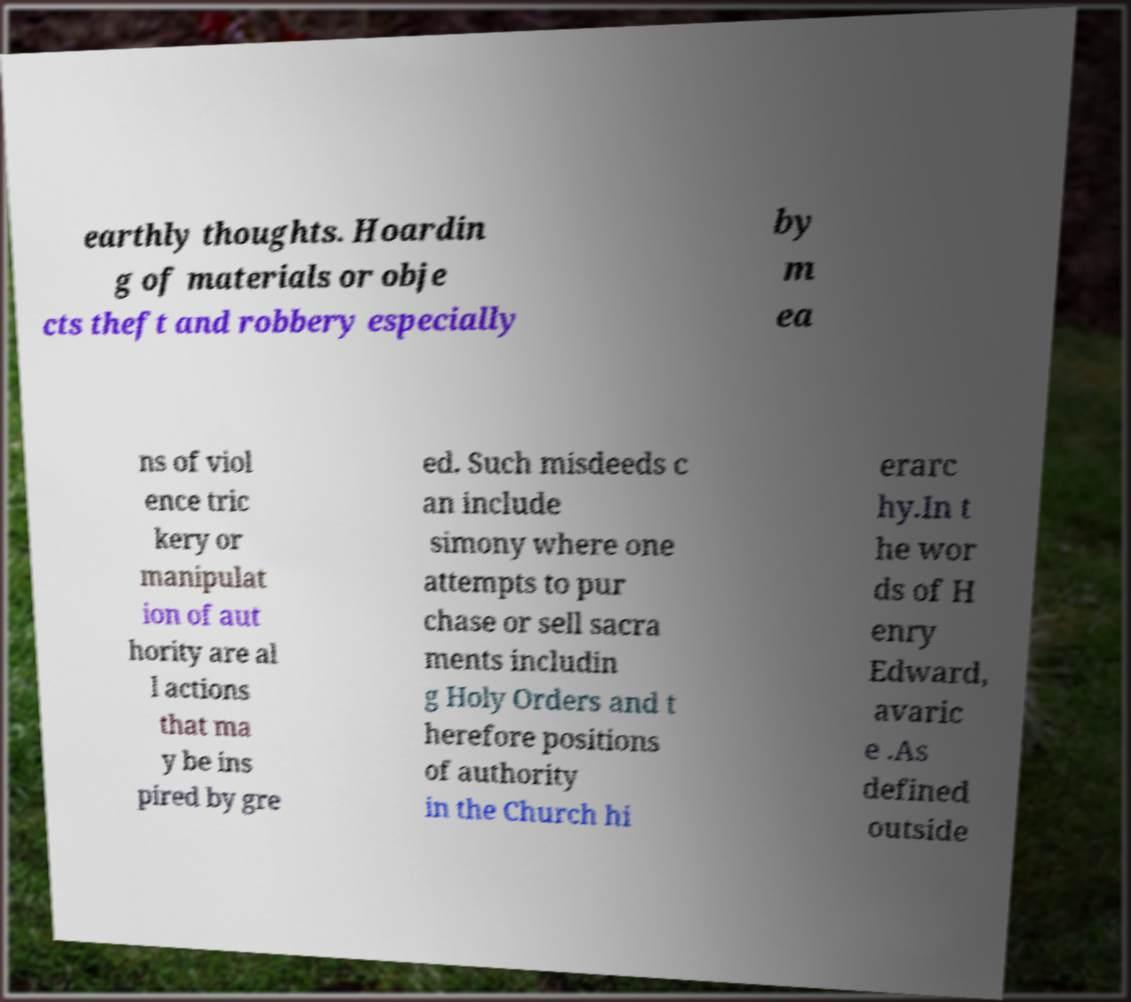There's text embedded in this image that I need extracted. Can you transcribe it verbatim? earthly thoughts. Hoardin g of materials or obje cts theft and robbery especially by m ea ns of viol ence tric kery or manipulat ion of aut hority are al l actions that ma y be ins pired by gre ed. Such misdeeds c an include simony where one attempts to pur chase or sell sacra ments includin g Holy Orders and t herefore positions of authority in the Church hi erarc hy.In t he wor ds of H enry Edward, avaric e .As defined outside 